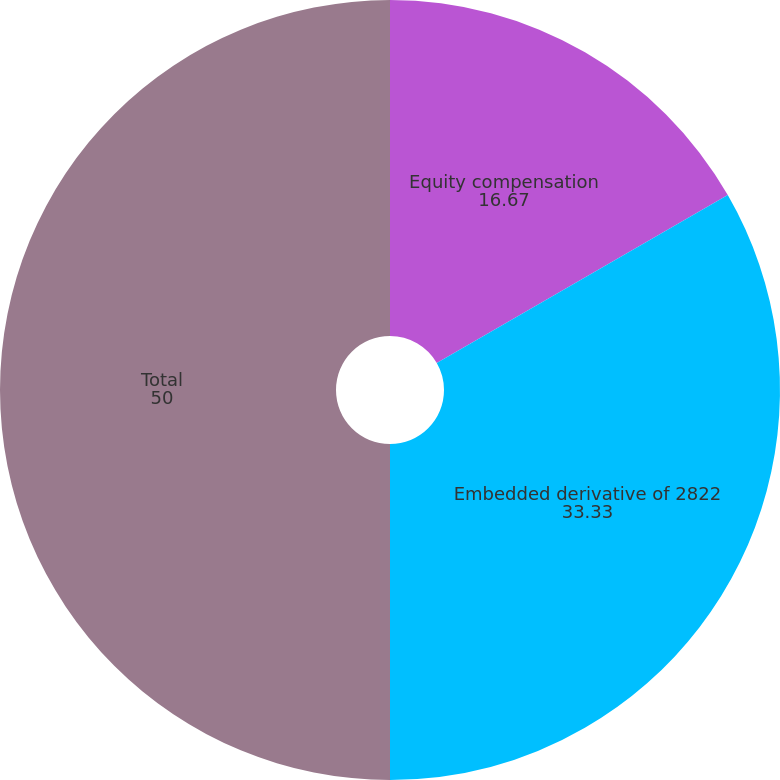Convert chart to OTSL. <chart><loc_0><loc_0><loc_500><loc_500><pie_chart><fcel>Equity compensation<fcel>Embedded derivative of 2822<fcel>Total<nl><fcel>16.67%<fcel>33.33%<fcel>50.0%<nl></chart> 